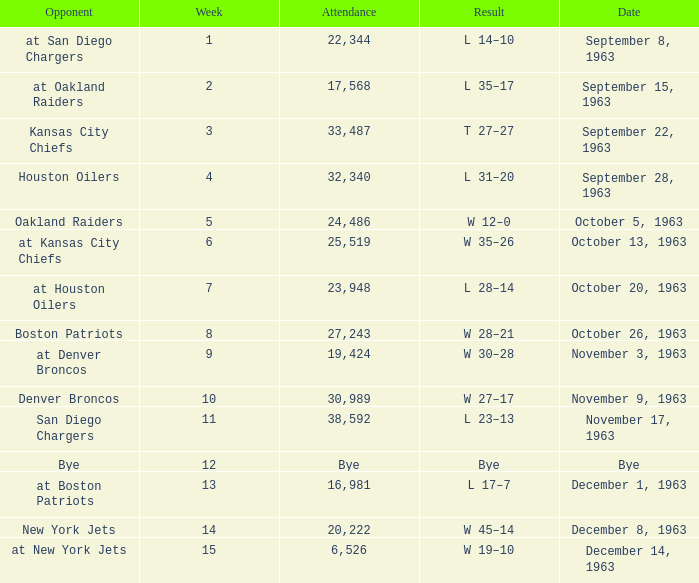Can you give me this table as a dict? {'header': ['Opponent', 'Week', 'Attendance', 'Result', 'Date'], 'rows': [['at San Diego Chargers', '1', '22,344', 'L 14–10', 'September 8, 1963'], ['at Oakland Raiders', '2', '17,568', 'L 35–17', 'September 15, 1963'], ['Kansas City Chiefs', '3', '33,487', 'T 27–27', 'September 22, 1963'], ['Houston Oilers', '4', '32,340', 'L 31–20', 'September 28, 1963'], ['Oakland Raiders', '5', '24,486', 'W 12–0', 'October 5, 1963'], ['at Kansas City Chiefs', '6', '25,519', 'W 35–26', 'October 13, 1963'], ['at Houston Oilers', '7', '23,948', 'L 28–14', 'October 20, 1963'], ['Boston Patriots', '8', '27,243', 'W 28–21', 'October 26, 1963'], ['at Denver Broncos', '9', '19,424', 'W 30–28', 'November 3, 1963'], ['Denver Broncos', '10', '30,989', 'W 27–17', 'November 9, 1963'], ['San Diego Chargers', '11', '38,592', 'L 23–13', 'November 17, 1963'], ['Bye', '12', 'Bye', 'Bye', 'Bye'], ['at Boston Patriots', '13', '16,981', 'L 17–7', 'December 1, 1963'], ['New York Jets', '14', '20,222', 'W 45–14', 'December 8, 1963'], ['at New York Jets', '15', '6,526', 'W 19–10', 'December 14, 1963']]} Which Opponent has a Date of november 17, 1963? San Diego Chargers. 